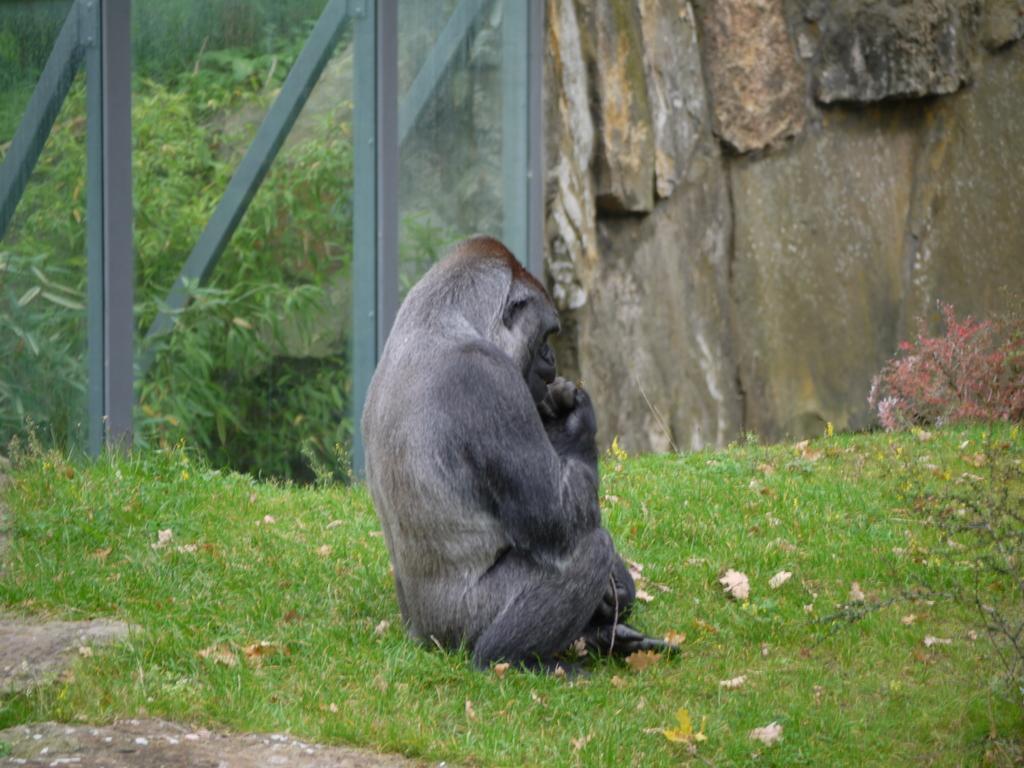Could you give a brief overview of what you see in this image? In this picture we can see a gorilla sitting on grass, trees, rods and in the background we can see wall. 